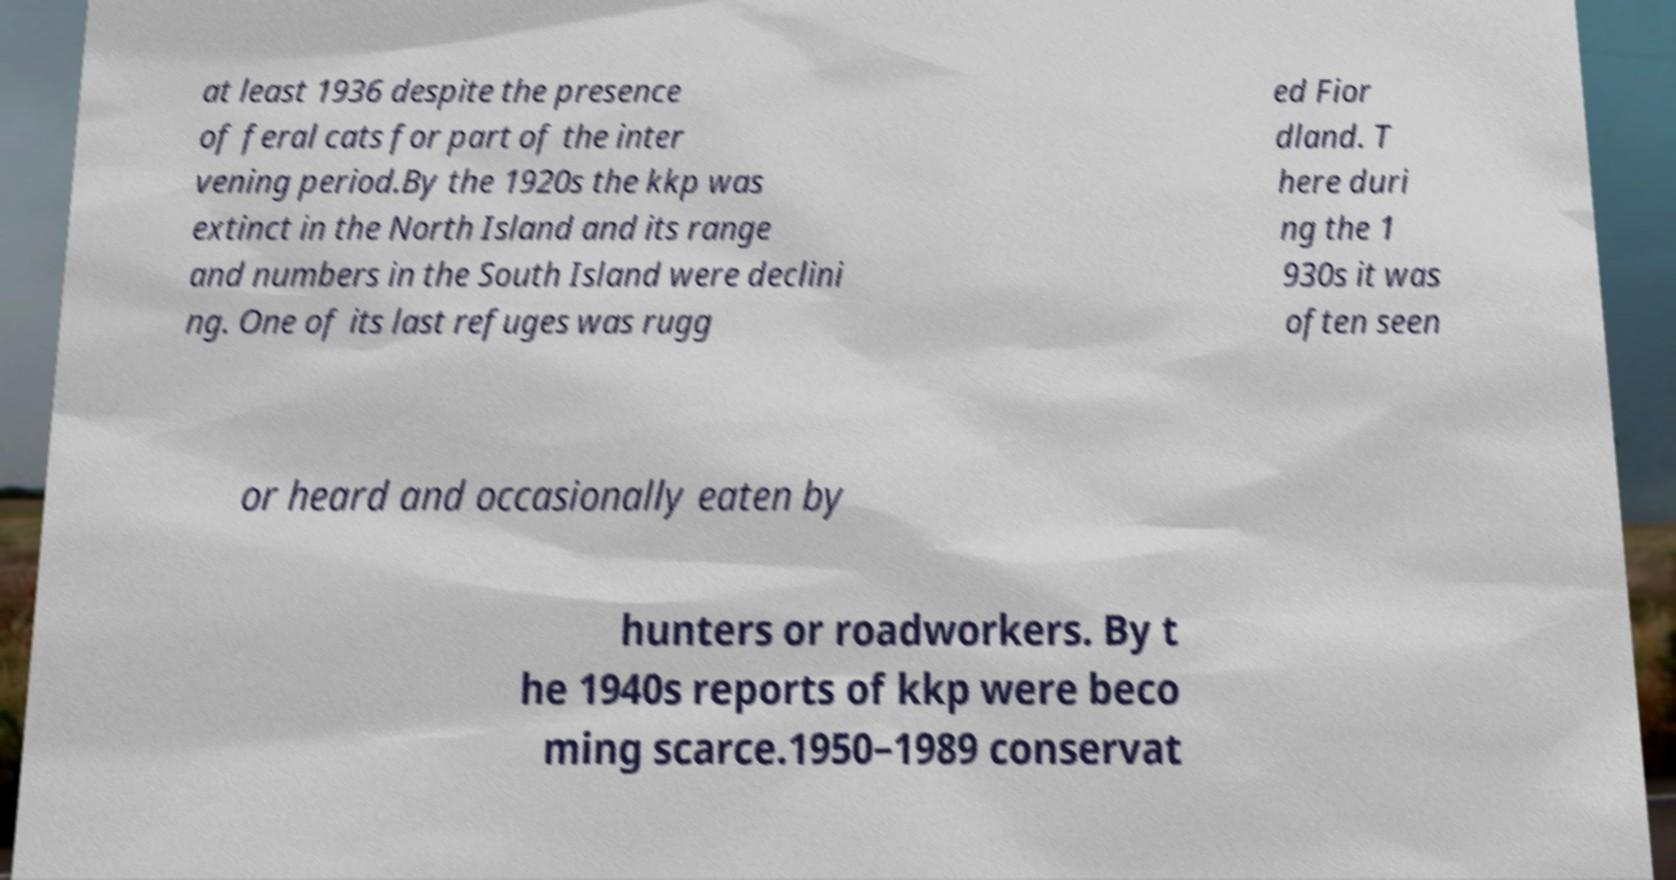Could you assist in decoding the text presented in this image and type it out clearly? at least 1936 despite the presence of feral cats for part of the inter vening period.By the 1920s the kkp was extinct in the North Island and its range and numbers in the South Island were declini ng. One of its last refuges was rugg ed Fior dland. T here duri ng the 1 930s it was often seen or heard and occasionally eaten by hunters or roadworkers. By t he 1940s reports of kkp were beco ming scarce.1950–1989 conservat 